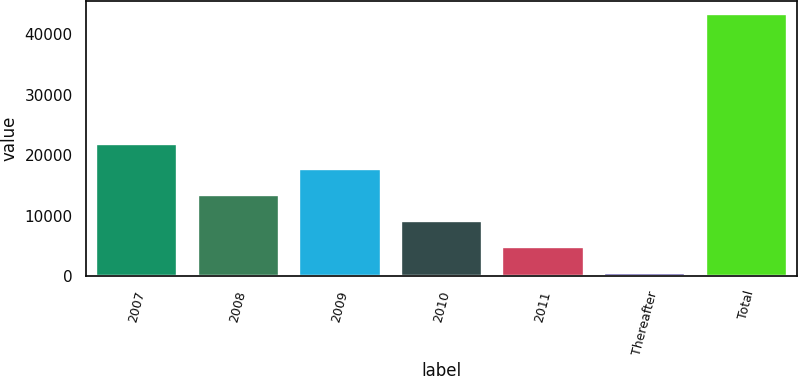<chart> <loc_0><loc_0><loc_500><loc_500><bar_chart><fcel>2007<fcel>2008<fcel>2009<fcel>2010<fcel>2011<fcel>Thereafter<fcel>Total<nl><fcel>21902.5<fcel>13364.3<fcel>17633.4<fcel>9095.2<fcel>4826.1<fcel>557<fcel>43248<nl></chart> 